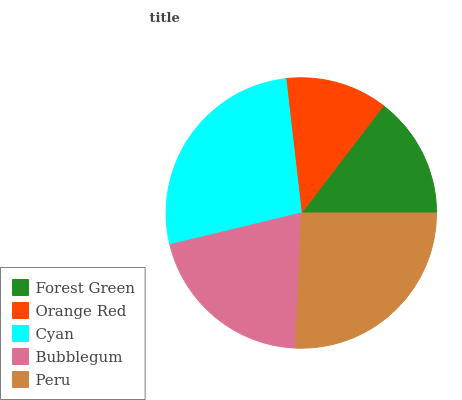Is Orange Red the minimum?
Answer yes or no. Yes. Is Cyan the maximum?
Answer yes or no. Yes. Is Cyan the minimum?
Answer yes or no. No. Is Orange Red the maximum?
Answer yes or no. No. Is Cyan greater than Orange Red?
Answer yes or no. Yes. Is Orange Red less than Cyan?
Answer yes or no. Yes. Is Orange Red greater than Cyan?
Answer yes or no. No. Is Cyan less than Orange Red?
Answer yes or no. No. Is Bubblegum the high median?
Answer yes or no. Yes. Is Bubblegum the low median?
Answer yes or no. Yes. Is Peru the high median?
Answer yes or no. No. Is Peru the low median?
Answer yes or no. No. 